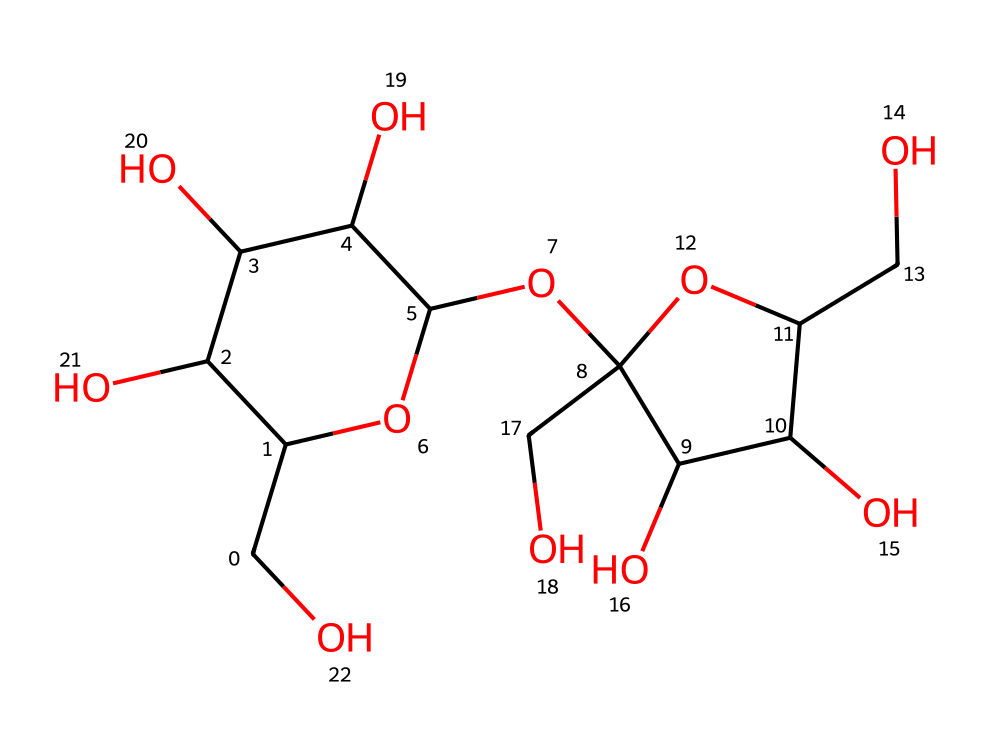What is the molecular formula of sucrose? To determine the molecular formula from the SMILES representation, we can count the number of each type of atom specified in the structure. The breakdown shows that sucrose consists of 12 carbon (C) atoms, 22 hydrogen (H) atoms, and 11 oxygen (O) atoms, leading to the molecular formula C12H22O11.
Answer: C12H22O11 How many rings are present in the structure of sucrose? By examining the SMILES string, we can identify the ring structures. In the representation, the numbers '1' and '2' indicate the start and end of two independent rings. This confirms that there are 2 cyclic structures in sucrose.
Answer: 2 What type of glycosidic bond is found in sucrose? Analyzing the structure, we can see that sucrose is composed of glucose and fructose units which are linked via an α-1,2-glycosidic bond. This is characterized by the link at the first carbon of glucose and the second carbon of fructose.
Answer: α-1,2-glycosidic What is the importance of sucrose in human nutrition? Sucrose serves as a primary energy source due to its composition of glucose and fructose which are easily metabolized. In examining the molecule, it provides quick energy to meet immediate metabolic needs.
Answer: energy source How many hydroxyl (OH) groups are present in sucrose? A careful examination of the structure reveals multiple hydroxyl functional groups (-OH). Counting those from both glucose and fructose parts, there are a total of 6 hydroxyl groups in sucrose.
Answer: 6 What is the role of sucrose in plants? In plants, sucrose acts as an important carbohydrate for energy transport and storage. The chemical structure shows how it is a disaccharide formed for efficient transport of energy in plant systems.
Answer: energy transport What physical property makes sucrose dissolve in water? The presence of multiple hydroxyl groups in the sucrose structure increases its polarity, enabling it to interact with water molecules, which explains its high solubility in water.
Answer: solubility 